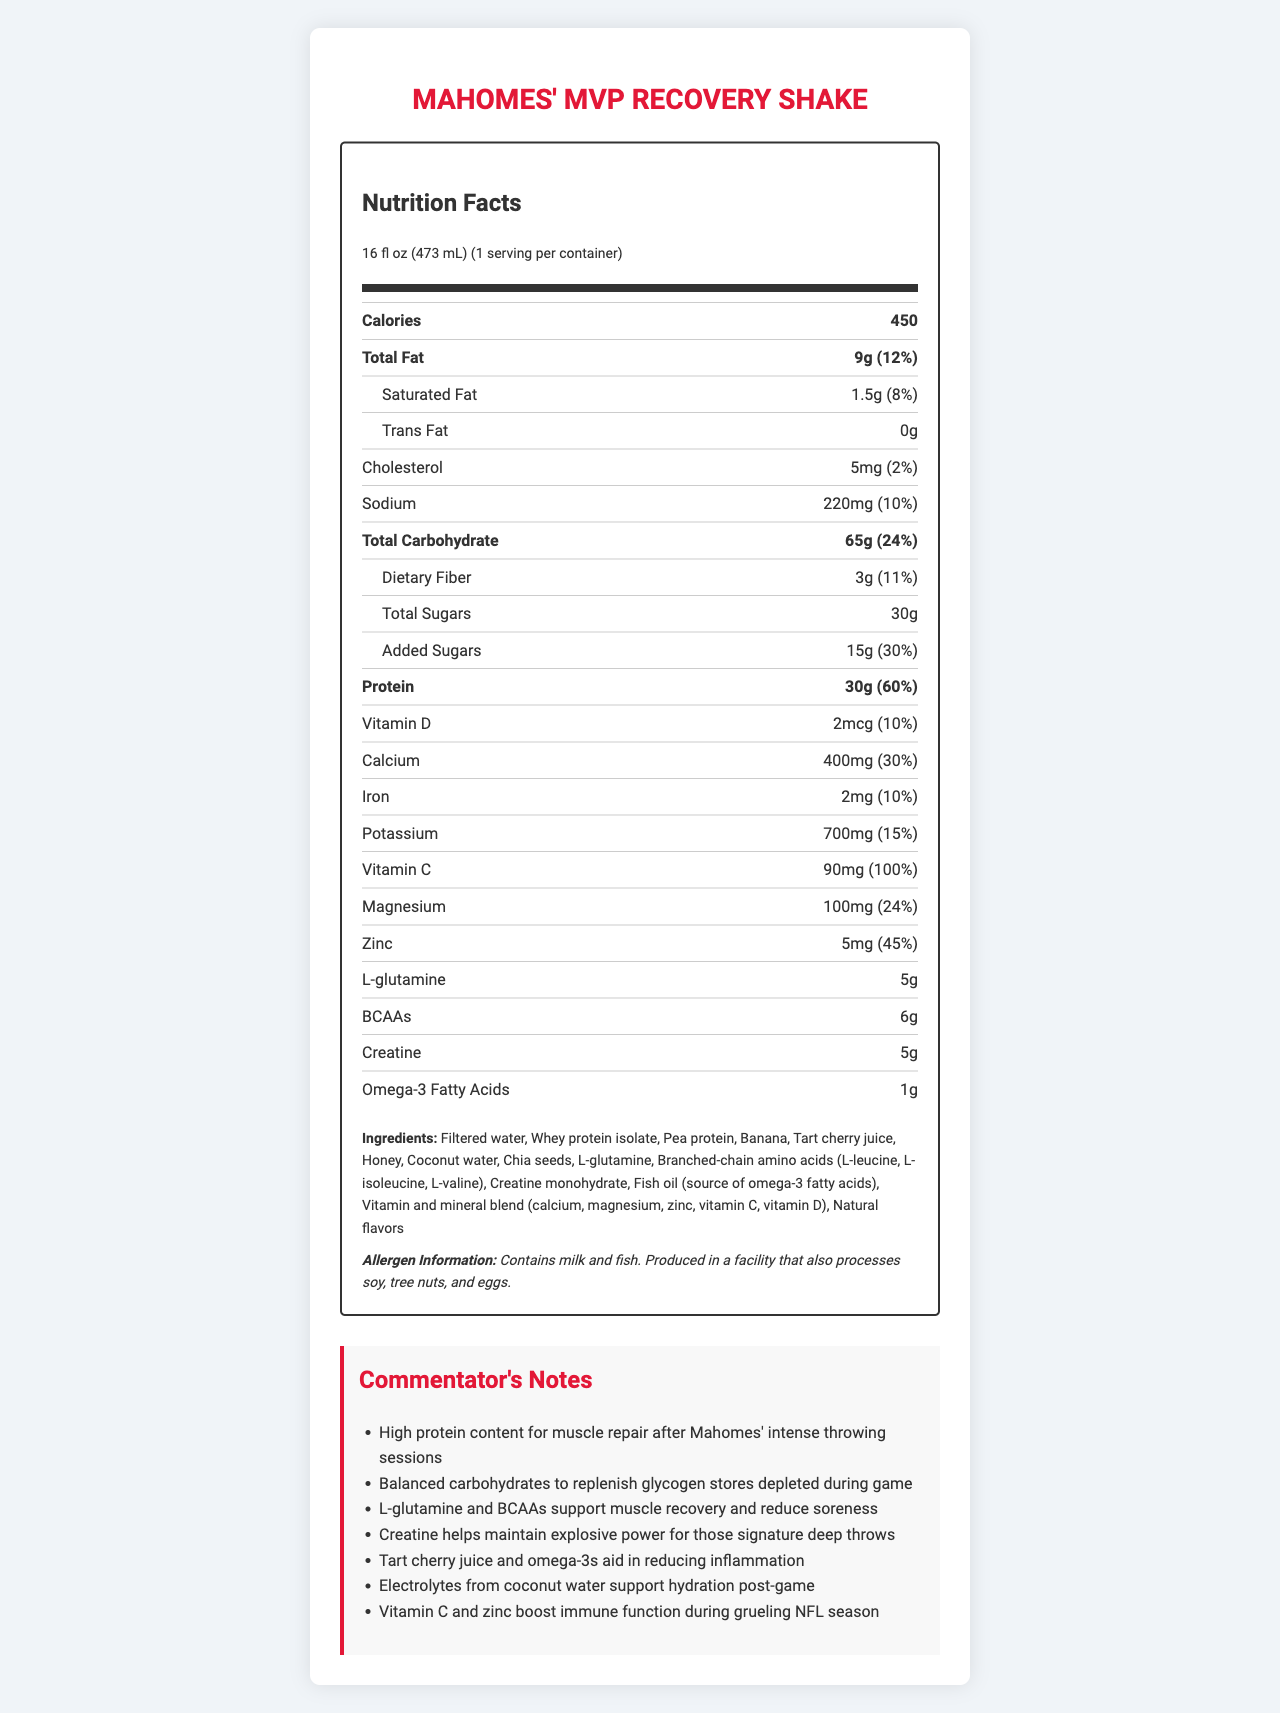what is the serving size of Mahomes' MVP Recovery Shake? The serving size is listed at the top of the Nutrition Facts section.
Answer: 16 fl oz (473 mL) how much protein is in one serving of the shake? The amount of protein per serving is mentioned under the nutrient information.
Answer: 30g what percentage of the daily value of calcium does the shake provide? The percentage daily value of calcium is indicated beside the calcium amount in the nutrient facts.
Answer: 30% what ingredients are used in Mahomes' MVP Recovery Shake? The ingredients are listed in a section at the bottom of the document.
Answer: Filtered water, Whey protein isolate, Pea protein, Banana, Tart cherry juice, Honey, Coconut water, Chia seeds, L-glutamine, Branched-chain amino acids (L-leucine, L-isoleucine, L-valine), Creatine monohydrate, Fish oil (source of omega-3 fatty acids), Vitamin and mineral blend (calcium, magnesium, zinc, vitamin C, vitamin D), Natural flavors how much L-glutamine is in the shake? The amount of L-glutamine is listed under the nutrient information.
Answer: 5g how much creatine is included in this recovery shake? The quantity of creatine is provided under the nutrient information.
Answer: 5g what is the allergen information for this product? The allergen information is listed in a specific section towards the bottom of the document.
Answer: Contains milk and fish. Produced in a facility that also processes soy, tree nuts, and eggs. which component is specifically highlighted for muscle repair in the commentator's notes? One of the commentator’s notes highlights the high protein content for muscle repair.
Answer: High protein content what is the calorie count of Mahomes' MVP Recovery Shake? The calorie count is prominently displayed under the nutrient information.
Answer: 450 which vitamin has the highest daily value percentage in this shake? A. Vitamin D B. Vitamin C C. Calcium D. Iron Vitamin C has a daily value percentage of 100%, which is the highest among the listed vitamins and minerals.
Answer: B. Vitamin C which component helps maintain explosive power according to the commentator's notes? A. L-glutamine B. Omega-3 Fatty Acids C. Creatine D. Magnesium The commentator notes that creatine helps maintain explosive power.
Answer: C. Creatine is this shake high in added sugars? The shake contains 15g of added sugars, amounting to 30% of the daily value, which is relatively high.
Answer: Yes summarize the main idea of Mahomes' MVP Recovery Shake Nutrition Facts. The document provides detailed nutrient information on Mahomes' MVP Recovery Shake, highlighting its benefits for muscle repair, recovery, and hydration, and includes a list of ingredients and allergen information.
Answer: Mahomes' MVP Recovery Shake is a recovery drink designed with muscle repair and overall recovery in mind. It features high amounts of protein, essential amino acids, and creatine for muscle recovery and power, along with vitamins and minerals to support overall health. Key ingredients include whey protein isolate, tart cherry juice, and coconut water, among others. can you find the country of manufacture in the document? The document does not provide any information regarding the country of manufacture.
Answer: Not enough information 